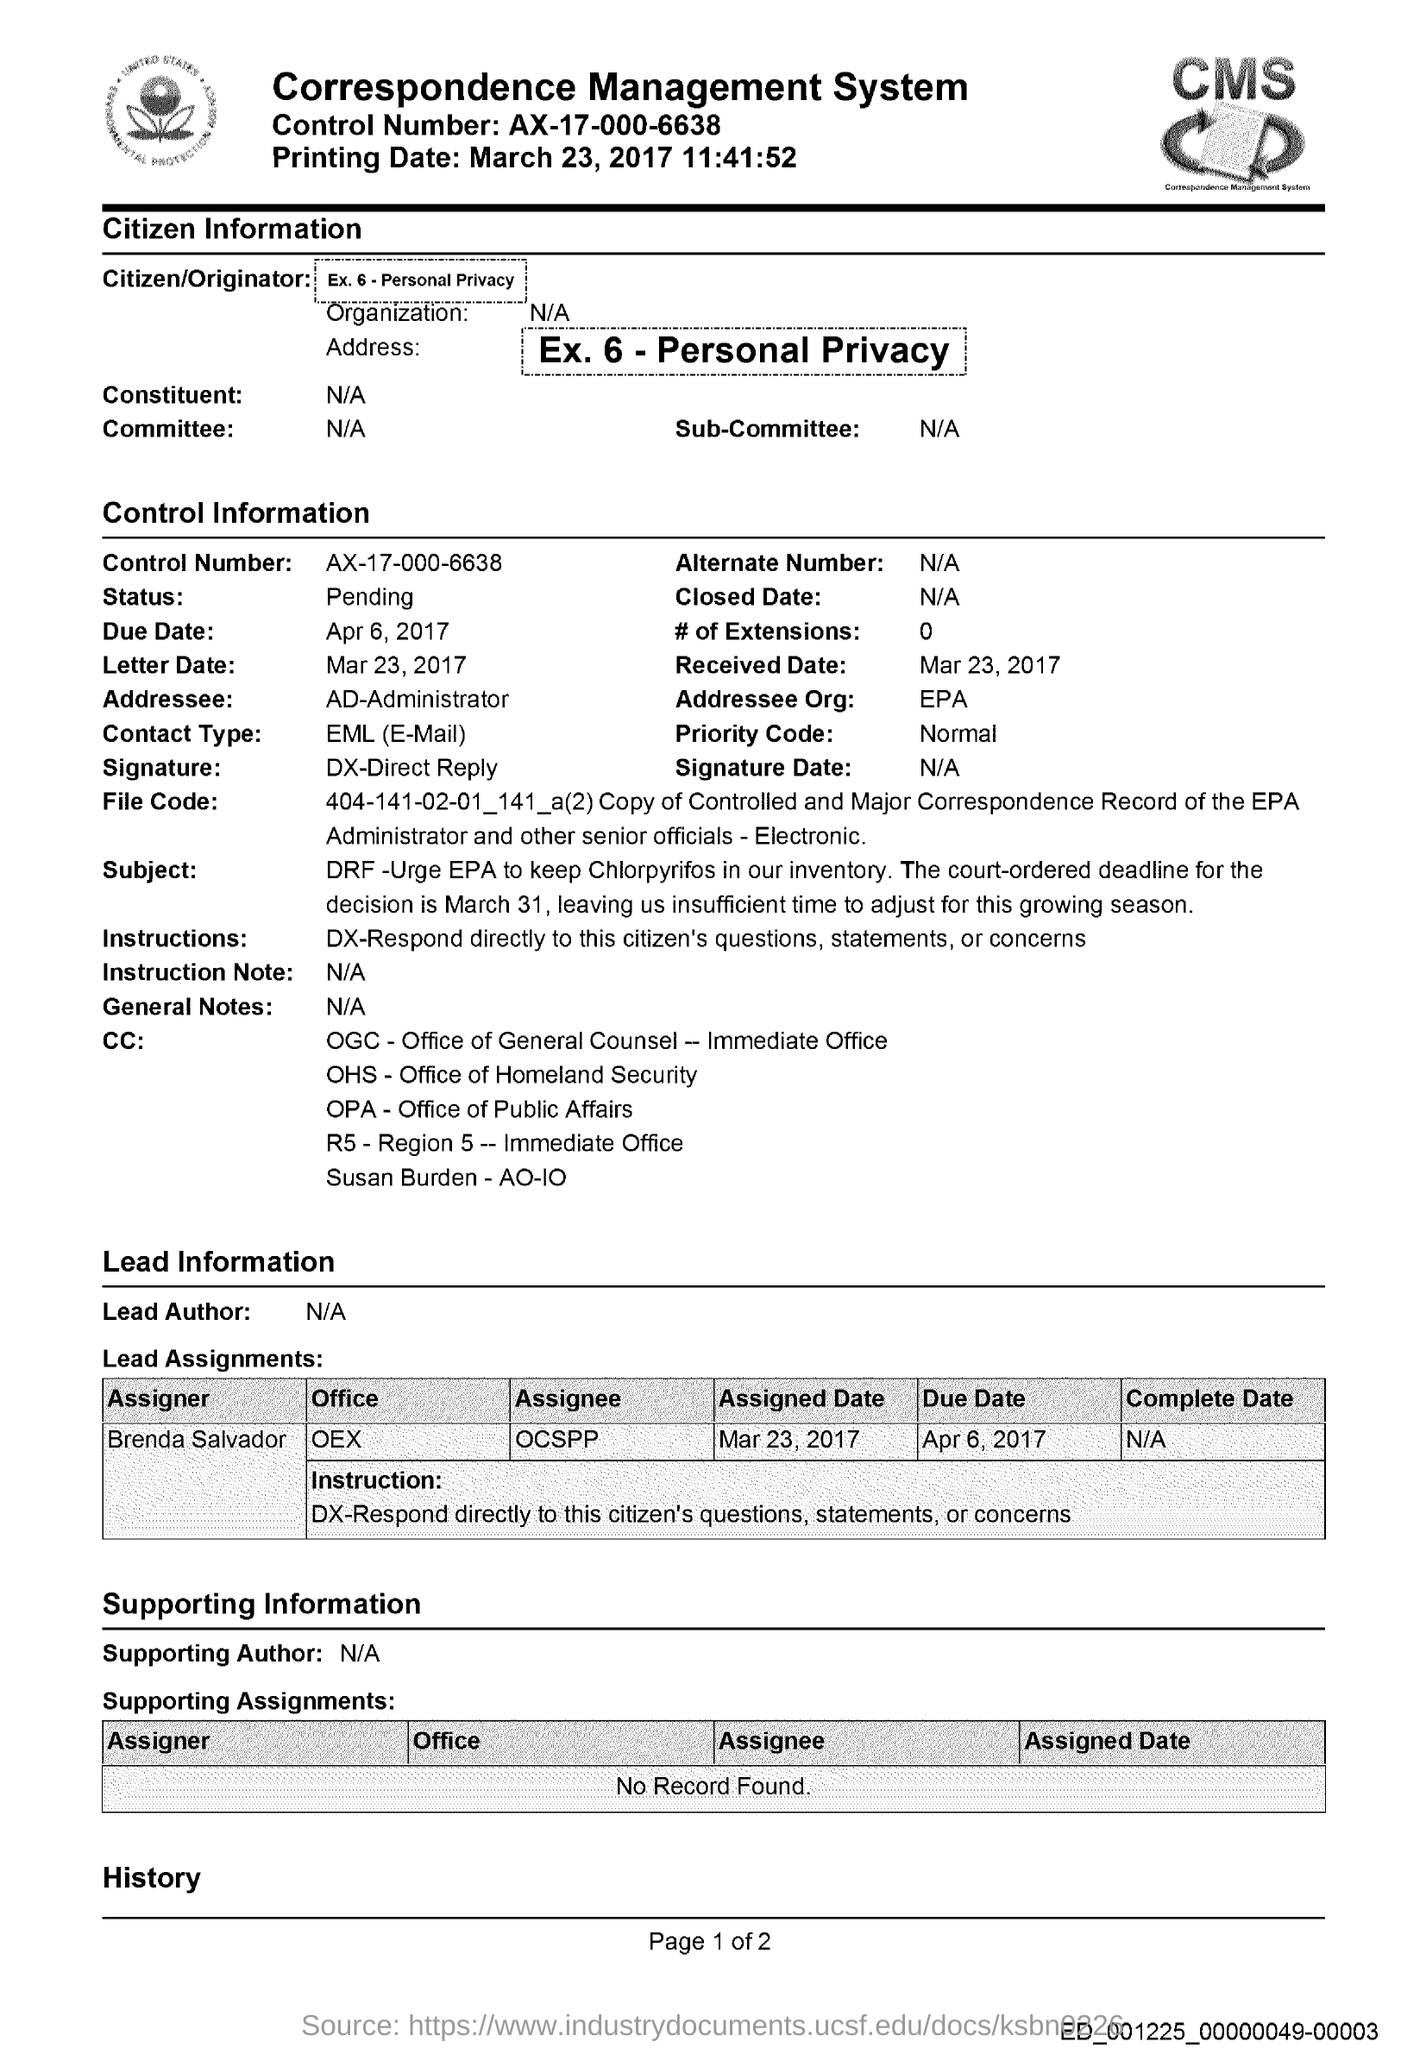Indicate a few pertinent items in this graphic. The control number given in the document is AX-17-000-6638. The printing date mentioned in the document is March 23, 2017 at 11:41:52. Who is the intended recipient of the control information as indicated in the control information? The priority code stated in the document is "Normal. The letter date mentioned in the document is March 23, 2017. 